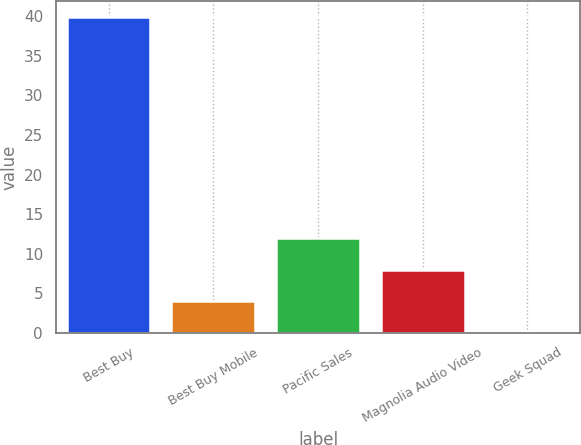Convert chart. <chart><loc_0><loc_0><loc_500><loc_500><bar_chart><fcel>Best Buy<fcel>Best Buy Mobile<fcel>Pacific Sales<fcel>Magnolia Audio Video<fcel>Geek Squad<nl><fcel>39.9<fcel>4<fcel>11.98<fcel>7.99<fcel>0.01<nl></chart> 